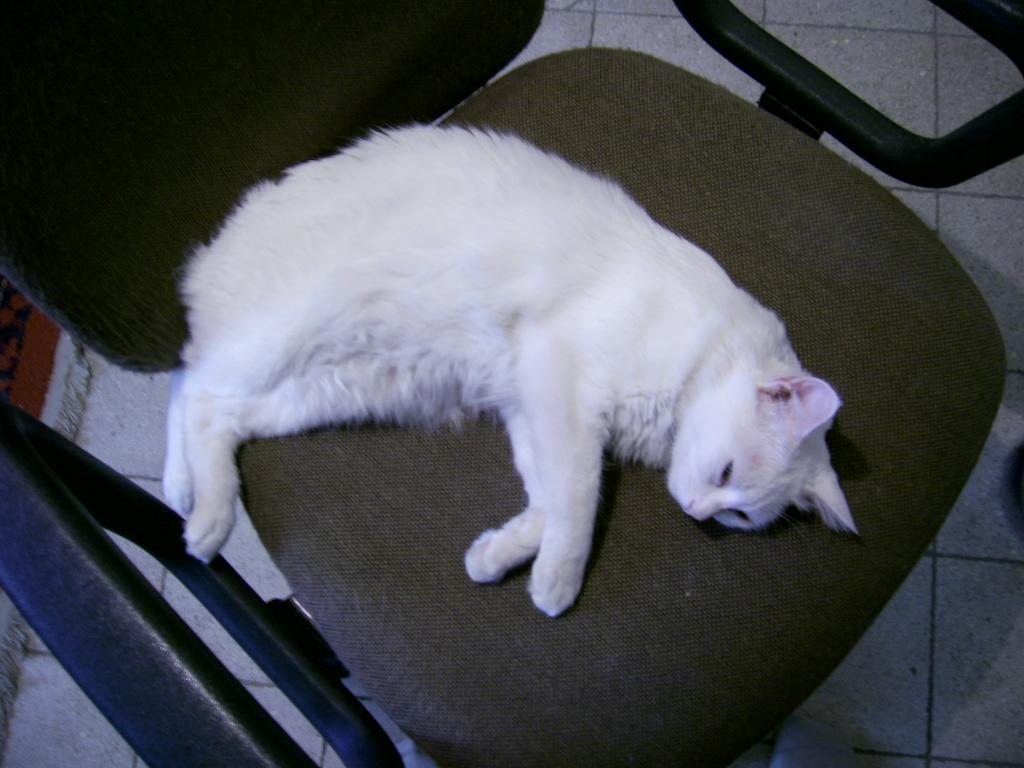Can you describe this image briefly? In the image there is a cat laying on a chair, it is in white color. 